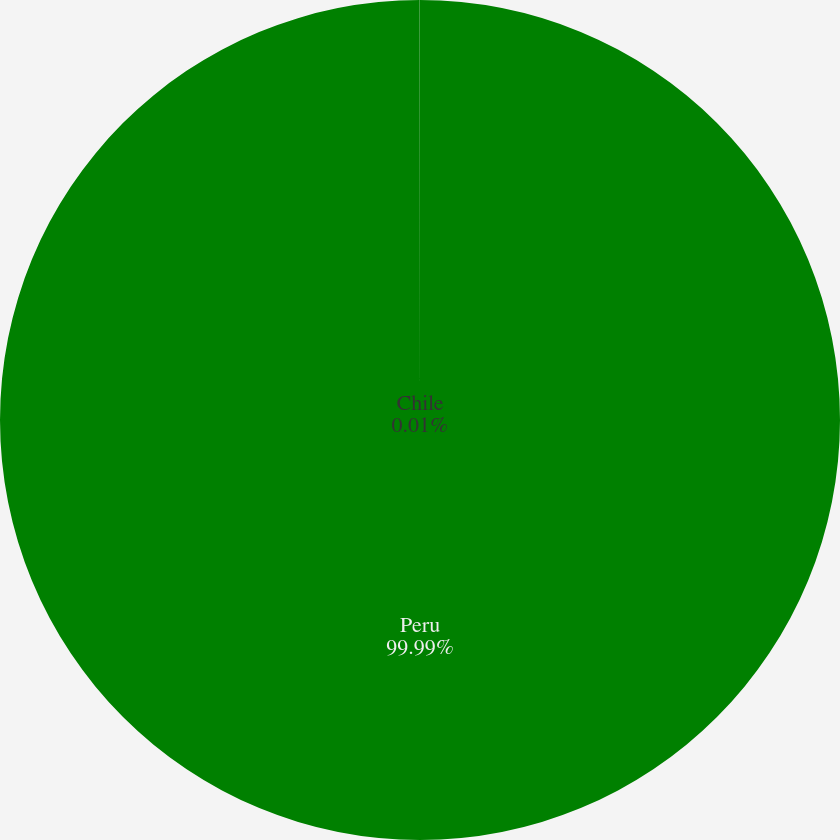Convert chart. <chart><loc_0><loc_0><loc_500><loc_500><pie_chart><fcel>Peru<fcel>Chile<nl><fcel>99.99%<fcel>0.01%<nl></chart> 